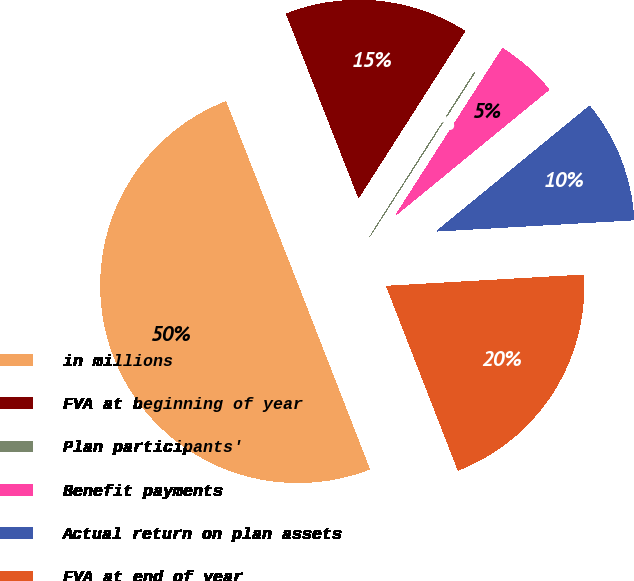<chart> <loc_0><loc_0><loc_500><loc_500><pie_chart><fcel>in millions<fcel>FVA at beginning of year<fcel>Plan participants'<fcel>Benefit payments<fcel>Actual return on plan assets<fcel>FVA at end of year<nl><fcel>49.95%<fcel>15.0%<fcel>0.02%<fcel>5.02%<fcel>10.01%<fcel>20.0%<nl></chart> 